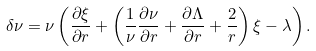Convert formula to latex. <formula><loc_0><loc_0><loc_500><loc_500>\delta \nu = \nu \left ( \frac { \partial \xi } { \partial r } + \left ( \frac { 1 } { \nu } \frac { \partial \nu } { \partial r } + \frac { \partial \Lambda } { \partial r } + \frac { 2 } { r } \right ) \xi - \lambda \right ) .</formula> 